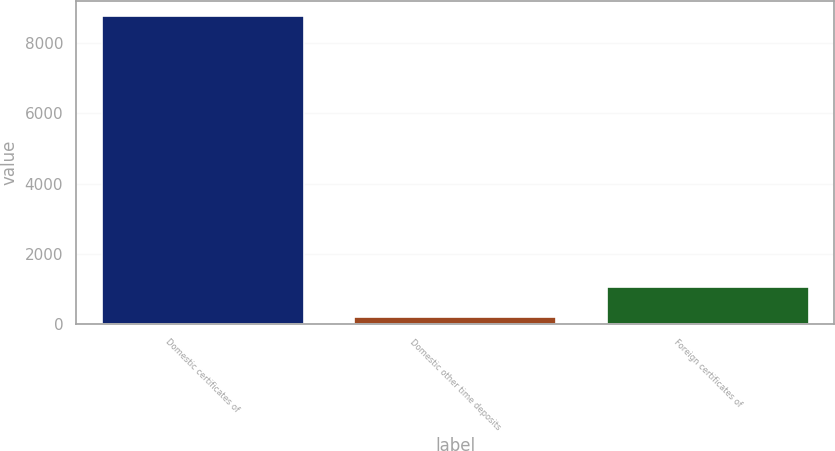<chart> <loc_0><loc_0><loc_500><loc_500><bar_chart><fcel>Domestic certificates of<fcel>Domestic other time deposits<fcel>Foreign certificates of<nl><fcel>8762<fcel>205<fcel>1060.7<nl></chart> 